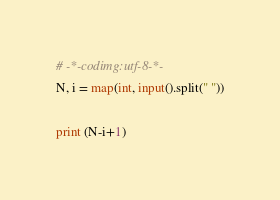Convert code to text. <code><loc_0><loc_0><loc_500><loc_500><_Python_># -*-codimg:utf-8-*-
N, i = map(int, input().split(" "))

print (N-i+1)</code> 